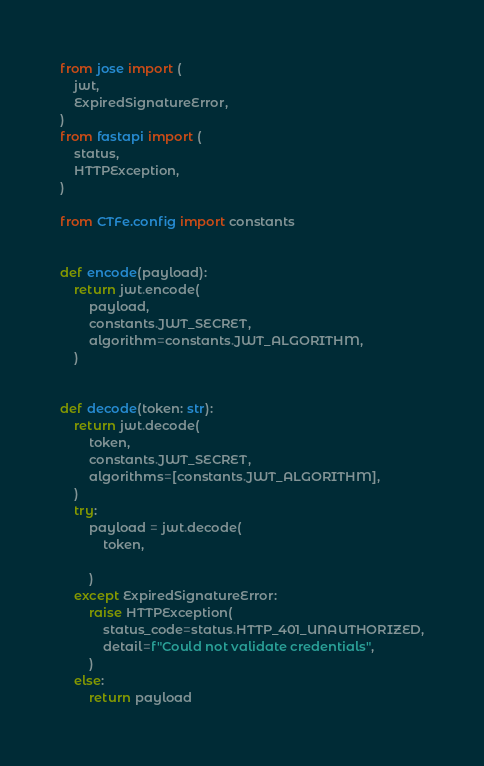<code> <loc_0><loc_0><loc_500><loc_500><_Python_>from jose import (
    jwt,
    ExpiredSignatureError,
)
from fastapi import (
    status,
    HTTPException,
)

from CTFe.config import constants


def encode(payload):
    return jwt.encode(
        payload,
        constants.JWT_SECRET,
        algorithm=constants.JWT_ALGORITHM,
    )


def decode(token: str):
    return jwt.decode(
        token,
        constants.JWT_SECRET,
        algorithms=[constants.JWT_ALGORITHM],
    )
    try:
        payload = jwt.decode(
            token,

        )
    except ExpiredSignatureError:
        raise HTTPException(
            status_code=status.HTTP_401_UNAUTHORIZED,
            detail=f"Could not validate credentials",
        )
    else:
        return payload
</code> 